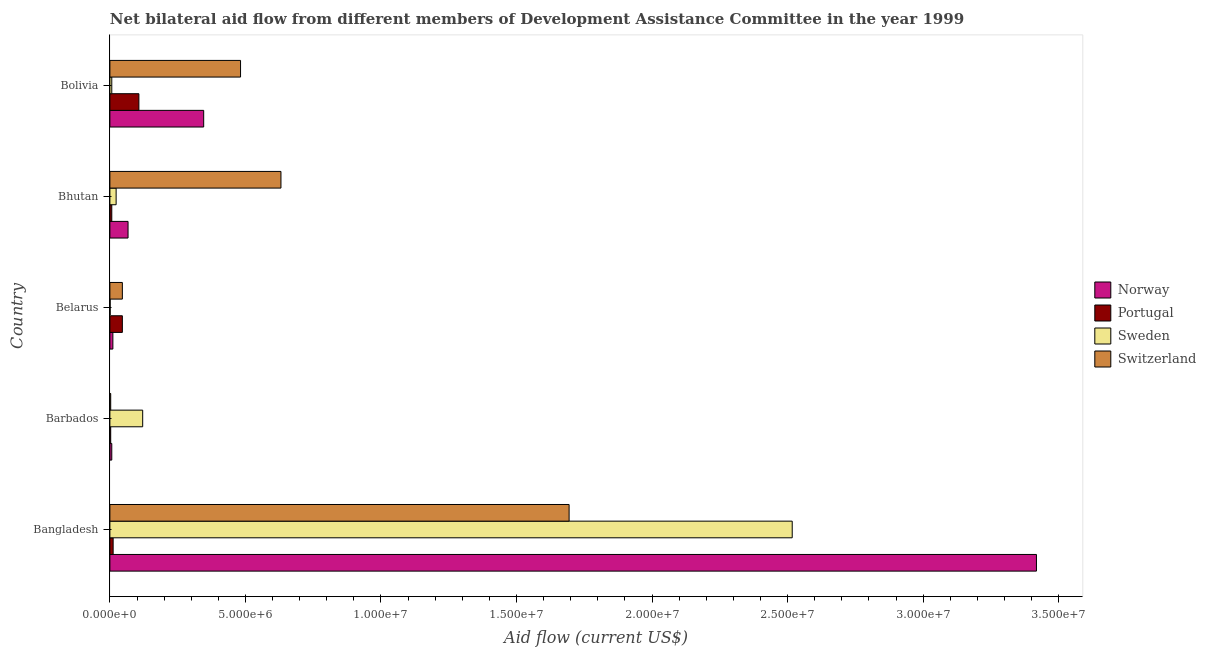How many groups of bars are there?
Your response must be concise. 5. Are the number of bars per tick equal to the number of legend labels?
Give a very brief answer. Yes. What is the label of the 4th group of bars from the top?
Provide a short and direct response. Barbados. In how many cases, is the number of bars for a given country not equal to the number of legend labels?
Your response must be concise. 0. What is the amount of aid given by switzerland in Belarus?
Provide a succinct answer. 4.60e+05. Across all countries, what is the maximum amount of aid given by portugal?
Keep it short and to the point. 1.07e+06. Across all countries, what is the minimum amount of aid given by portugal?
Provide a succinct answer. 3.00e+04. In which country was the amount of aid given by switzerland maximum?
Provide a succinct answer. Bangladesh. In which country was the amount of aid given by switzerland minimum?
Ensure brevity in your answer.  Barbados. What is the total amount of aid given by norway in the graph?
Give a very brief answer. 3.85e+07. What is the difference between the amount of aid given by sweden in Barbados and that in Belarus?
Offer a very short reply. 1.20e+06. What is the difference between the amount of aid given by switzerland in Bangladesh and the amount of aid given by norway in Belarus?
Provide a succinct answer. 1.68e+07. What is the difference between the amount of aid given by portugal and amount of aid given by switzerland in Belarus?
Provide a succinct answer. 0. What is the ratio of the amount of aid given by switzerland in Bangladesh to that in Bhutan?
Offer a terse response. 2.69. What is the difference between the highest and the second highest amount of aid given by portugal?
Offer a very short reply. 6.10e+05. What is the difference between the highest and the lowest amount of aid given by sweden?
Give a very brief answer. 2.52e+07. In how many countries, is the amount of aid given by norway greater than the average amount of aid given by norway taken over all countries?
Offer a terse response. 1. Is it the case that in every country, the sum of the amount of aid given by portugal and amount of aid given by switzerland is greater than the sum of amount of aid given by norway and amount of aid given by sweden?
Keep it short and to the point. No. What does the 3rd bar from the top in Barbados represents?
Give a very brief answer. Portugal. What does the 2nd bar from the bottom in Bolivia represents?
Your response must be concise. Portugal. Is it the case that in every country, the sum of the amount of aid given by norway and amount of aid given by portugal is greater than the amount of aid given by sweden?
Provide a succinct answer. No. What is the difference between two consecutive major ticks on the X-axis?
Keep it short and to the point. 5.00e+06. How many legend labels are there?
Your answer should be very brief. 4. What is the title of the graph?
Offer a terse response. Net bilateral aid flow from different members of Development Assistance Committee in the year 1999. Does "Secondary schools" appear as one of the legend labels in the graph?
Your answer should be very brief. No. What is the Aid flow (current US$) of Norway in Bangladesh?
Your answer should be compact. 3.42e+07. What is the Aid flow (current US$) of Sweden in Bangladesh?
Your response must be concise. 2.52e+07. What is the Aid flow (current US$) in Switzerland in Bangladesh?
Keep it short and to the point. 1.69e+07. What is the Aid flow (current US$) of Norway in Barbados?
Provide a short and direct response. 7.00e+04. What is the Aid flow (current US$) in Sweden in Barbados?
Offer a very short reply. 1.21e+06. What is the Aid flow (current US$) of Switzerland in Barbados?
Provide a succinct answer. 3.00e+04. What is the Aid flow (current US$) in Norway in Bhutan?
Offer a terse response. 6.70e+05. What is the Aid flow (current US$) of Portugal in Bhutan?
Keep it short and to the point. 7.00e+04. What is the Aid flow (current US$) of Sweden in Bhutan?
Your answer should be very brief. 2.30e+05. What is the Aid flow (current US$) of Switzerland in Bhutan?
Offer a very short reply. 6.31e+06. What is the Aid flow (current US$) in Norway in Bolivia?
Offer a very short reply. 3.46e+06. What is the Aid flow (current US$) in Portugal in Bolivia?
Ensure brevity in your answer.  1.07e+06. What is the Aid flow (current US$) of Switzerland in Bolivia?
Offer a terse response. 4.82e+06. Across all countries, what is the maximum Aid flow (current US$) in Norway?
Make the answer very short. 3.42e+07. Across all countries, what is the maximum Aid flow (current US$) of Portugal?
Offer a terse response. 1.07e+06. Across all countries, what is the maximum Aid flow (current US$) of Sweden?
Provide a succinct answer. 2.52e+07. Across all countries, what is the maximum Aid flow (current US$) in Switzerland?
Offer a very short reply. 1.69e+07. Across all countries, what is the minimum Aid flow (current US$) in Norway?
Provide a short and direct response. 7.00e+04. Across all countries, what is the minimum Aid flow (current US$) in Portugal?
Offer a very short reply. 3.00e+04. Across all countries, what is the minimum Aid flow (current US$) in Sweden?
Offer a terse response. 10000. What is the total Aid flow (current US$) in Norway in the graph?
Your answer should be very brief. 3.85e+07. What is the total Aid flow (current US$) of Portugal in the graph?
Your answer should be very brief. 1.75e+06. What is the total Aid flow (current US$) in Sweden in the graph?
Your answer should be very brief. 2.67e+07. What is the total Aid flow (current US$) of Switzerland in the graph?
Your answer should be very brief. 2.86e+07. What is the difference between the Aid flow (current US$) in Norway in Bangladesh and that in Barbados?
Give a very brief answer. 3.41e+07. What is the difference between the Aid flow (current US$) of Portugal in Bangladesh and that in Barbados?
Provide a succinct answer. 9.00e+04. What is the difference between the Aid flow (current US$) in Sweden in Bangladesh and that in Barbados?
Provide a short and direct response. 2.40e+07. What is the difference between the Aid flow (current US$) of Switzerland in Bangladesh and that in Barbados?
Give a very brief answer. 1.69e+07. What is the difference between the Aid flow (current US$) in Norway in Bangladesh and that in Belarus?
Offer a very short reply. 3.41e+07. What is the difference between the Aid flow (current US$) in Portugal in Bangladesh and that in Belarus?
Your response must be concise. -3.40e+05. What is the difference between the Aid flow (current US$) of Sweden in Bangladesh and that in Belarus?
Give a very brief answer. 2.52e+07. What is the difference between the Aid flow (current US$) in Switzerland in Bangladesh and that in Belarus?
Give a very brief answer. 1.65e+07. What is the difference between the Aid flow (current US$) in Norway in Bangladesh and that in Bhutan?
Provide a succinct answer. 3.35e+07. What is the difference between the Aid flow (current US$) in Portugal in Bangladesh and that in Bhutan?
Give a very brief answer. 5.00e+04. What is the difference between the Aid flow (current US$) of Sweden in Bangladesh and that in Bhutan?
Ensure brevity in your answer.  2.49e+07. What is the difference between the Aid flow (current US$) in Switzerland in Bangladesh and that in Bhutan?
Give a very brief answer. 1.06e+07. What is the difference between the Aid flow (current US$) in Norway in Bangladesh and that in Bolivia?
Make the answer very short. 3.07e+07. What is the difference between the Aid flow (current US$) of Portugal in Bangladesh and that in Bolivia?
Your answer should be compact. -9.50e+05. What is the difference between the Aid flow (current US$) in Sweden in Bangladesh and that in Bolivia?
Your answer should be very brief. 2.51e+07. What is the difference between the Aid flow (current US$) of Switzerland in Bangladesh and that in Bolivia?
Offer a very short reply. 1.21e+07. What is the difference between the Aid flow (current US$) in Portugal in Barbados and that in Belarus?
Provide a succinct answer. -4.30e+05. What is the difference between the Aid flow (current US$) in Sweden in Barbados and that in Belarus?
Offer a very short reply. 1.20e+06. What is the difference between the Aid flow (current US$) of Switzerland in Barbados and that in Belarus?
Keep it short and to the point. -4.30e+05. What is the difference between the Aid flow (current US$) of Norway in Barbados and that in Bhutan?
Give a very brief answer. -6.00e+05. What is the difference between the Aid flow (current US$) in Portugal in Barbados and that in Bhutan?
Your answer should be very brief. -4.00e+04. What is the difference between the Aid flow (current US$) in Sweden in Barbados and that in Bhutan?
Make the answer very short. 9.80e+05. What is the difference between the Aid flow (current US$) in Switzerland in Barbados and that in Bhutan?
Your answer should be compact. -6.28e+06. What is the difference between the Aid flow (current US$) in Norway in Barbados and that in Bolivia?
Ensure brevity in your answer.  -3.39e+06. What is the difference between the Aid flow (current US$) in Portugal in Barbados and that in Bolivia?
Offer a very short reply. -1.04e+06. What is the difference between the Aid flow (current US$) of Sweden in Barbados and that in Bolivia?
Offer a terse response. 1.14e+06. What is the difference between the Aid flow (current US$) in Switzerland in Barbados and that in Bolivia?
Offer a very short reply. -4.79e+06. What is the difference between the Aid flow (current US$) in Norway in Belarus and that in Bhutan?
Give a very brief answer. -5.60e+05. What is the difference between the Aid flow (current US$) in Portugal in Belarus and that in Bhutan?
Provide a short and direct response. 3.90e+05. What is the difference between the Aid flow (current US$) of Sweden in Belarus and that in Bhutan?
Provide a short and direct response. -2.20e+05. What is the difference between the Aid flow (current US$) in Switzerland in Belarus and that in Bhutan?
Provide a succinct answer. -5.85e+06. What is the difference between the Aid flow (current US$) of Norway in Belarus and that in Bolivia?
Your answer should be compact. -3.35e+06. What is the difference between the Aid flow (current US$) in Portugal in Belarus and that in Bolivia?
Offer a terse response. -6.10e+05. What is the difference between the Aid flow (current US$) of Sweden in Belarus and that in Bolivia?
Provide a short and direct response. -6.00e+04. What is the difference between the Aid flow (current US$) in Switzerland in Belarus and that in Bolivia?
Provide a succinct answer. -4.36e+06. What is the difference between the Aid flow (current US$) in Norway in Bhutan and that in Bolivia?
Provide a succinct answer. -2.79e+06. What is the difference between the Aid flow (current US$) of Portugal in Bhutan and that in Bolivia?
Ensure brevity in your answer.  -1.00e+06. What is the difference between the Aid flow (current US$) of Sweden in Bhutan and that in Bolivia?
Keep it short and to the point. 1.60e+05. What is the difference between the Aid flow (current US$) in Switzerland in Bhutan and that in Bolivia?
Offer a very short reply. 1.49e+06. What is the difference between the Aid flow (current US$) of Norway in Bangladesh and the Aid flow (current US$) of Portugal in Barbados?
Provide a short and direct response. 3.42e+07. What is the difference between the Aid flow (current US$) in Norway in Bangladesh and the Aid flow (current US$) in Sweden in Barbados?
Offer a terse response. 3.30e+07. What is the difference between the Aid flow (current US$) in Norway in Bangladesh and the Aid flow (current US$) in Switzerland in Barbados?
Offer a terse response. 3.42e+07. What is the difference between the Aid flow (current US$) of Portugal in Bangladesh and the Aid flow (current US$) of Sweden in Barbados?
Give a very brief answer. -1.09e+06. What is the difference between the Aid flow (current US$) in Sweden in Bangladesh and the Aid flow (current US$) in Switzerland in Barbados?
Make the answer very short. 2.51e+07. What is the difference between the Aid flow (current US$) in Norway in Bangladesh and the Aid flow (current US$) in Portugal in Belarus?
Your answer should be compact. 3.37e+07. What is the difference between the Aid flow (current US$) of Norway in Bangladesh and the Aid flow (current US$) of Sweden in Belarus?
Provide a succinct answer. 3.42e+07. What is the difference between the Aid flow (current US$) of Norway in Bangladesh and the Aid flow (current US$) of Switzerland in Belarus?
Your response must be concise. 3.37e+07. What is the difference between the Aid flow (current US$) in Sweden in Bangladesh and the Aid flow (current US$) in Switzerland in Belarus?
Your answer should be compact. 2.47e+07. What is the difference between the Aid flow (current US$) of Norway in Bangladesh and the Aid flow (current US$) of Portugal in Bhutan?
Provide a succinct answer. 3.41e+07. What is the difference between the Aid flow (current US$) in Norway in Bangladesh and the Aid flow (current US$) in Sweden in Bhutan?
Offer a terse response. 3.40e+07. What is the difference between the Aid flow (current US$) of Norway in Bangladesh and the Aid flow (current US$) of Switzerland in Bhutan?
Your answer should be very brief. 2.79e+07. What is the difference between the Aid flow (current US$) in Portugal in Bangladesh and the Aid flow (current US$) in Sweden in Bhutan?
Your response must be concise. -1.10e+05. What is the difference between the Aid flow (current US$) in Portugal in Bangladesh and the Aid flow (current US$) in Switzerland in Bhutan?
Provide a succinct answer. -6.19e+06. What is the difference between the Aid flow (current US$) in Sweden in Bangladesh and the Aid flow (current US$) in Switzerland in Bhutan?
Offer a terse response. 1.89e+07. What is the difference between the Aid flow (current US$) in Norway in Bangladesh and the Aid flow (current US$) in Portugal in Bolivia?
Your response must be concise. 3.31e+07. What is the difference between the Aid flow (current US$) of Norway in Bangladesh and the Aid flow (current US$) of Sweden in Bolivia?
Provide a succinct answer. 3.41e+07. What is the difference between the Aid flow (current US$) in Norway in Bangladesh and the Aid flow (current US$) in Switzerland in Bolivia?
Provide a short and direct response. 2.94e+07. What is the difference between the Aid flow (current US$) of Portugal in Bangladesh and the Aid flow (current US$) of Switzerland in Bolivia?
Offer a terse response. -4.70e+06. What is the difference between the Aid flow (current US$) of Sweden in Bangladesh and the Aid flow (current US$) of Switzerland in Bolivia?
Make the answer very short. 2.04e+07. What is the difference between the Aid flow (current US$) of Norway in Barbados and the Aid flow (current US$) of Portugal in Belarus?
Provide a succinct answer. -3.90e+05. What is the difference between the Aid flow (current US$) of Norway in Barbados and the Aid flow (current US$) of Switzerland in Belarus?
Ensure brevity in your answer.  -3.90e+05. What is the difference between the Aid flow (current US$) of Portugal in Barbados and the Aid flow (current US$) of Switzerland in Belarus?
Give a very brief answer. -4.30e+05. What is the difference between the Aid flow (current US$) of Sweden in Barbados and the Aid flow (current US$) of Switzerland in Belarus?
Give a very brief answer. 7.50e+05. What is the difference between the Aid flow (current US$) of Norway in Barbados and the Aid flow (current US$) of Sweden in Bhutan?
Give a very brief answer. -1.60e+05. What is the difference between the Aid flow (current US$) in Norway in Barbados and the Aid flow (current US$) in Switzerland in Bhutan?
Ensure brevity in your answer.  -6.24e+06. What is the difference between the Aid flow (current US$) of Portugal in Barbados and the Aid flow (current US$) of Sweden in Bhutan?
Provide a short and direct response. -2.00e+05. What is the difference between the Aid flow (current US$) in Portugal in Barbados and the Aid flow (current US$) in Switzerland in Bhutan?
Provide a succinct answer. -6.28e+06. What is the difference between the Aid flow (current US$) of Sweden in Barbados and the Aid flow (current US$) of Switzerland in Bhutan?
Make the answer very short. -5.10e+06. What is the difference between the Aid flow (current US$) of Norway in Barbados and the Aid flow (current US$) of Sweden in Bolivia?
Keep it short and to the point. 0. What is the difference between the Aid flow (current US$) in Norway in Barbados and the Aid flow (current US$) in Switzerland in Bolivia?
Ensure brevity in your answer.  -4.75e+06. What is the difference between the Aid flow (current US$) in Portugal in Barbados and the Aid flow (current US$) in Switzerland in Bolivia?
Keep it short and to the point. -4.79e+06. What is the difference between the Aid flow (current US$) of Sweden in Barbados and the Aid flow (current US$) of Switzerland in Bolivia?
Your answer should be compact. -3.61e+06. What is the difference between the Aid flow (current US$) in Norway in Belarus and the Aid flow (current US$) in Portugal in Bhutan?
Your answer should be compact. 4.00e+04. What is the difference between the Aid flow (current US$) in Norway in Belarus and the Aid flow (current US$) in Switzerland in Bhutan?
Make the answer very short. -6.20e+06. What is the difference between the Aid flow (current US$) in Portugal in Belarus and the Aid flow (current US$) in Switzerland in Bhutan?
Ensure brevity in your answer.  -5.85e+06. What is the difference between the Aid flow (current US$) in Sweden in Belarus and the Aid flow (current US$) in Switzerland in Bhutan?
Your answer should be very brief. -6.30e+06. What is the difference between the Aid flow (current US$) in Norway in Belarus and the Aid flow (current US$) in Portugal in Bolivia?
Make the answer very short. -9.60e+05. What is the difference between the Aid flow (current US$) in Norway in Belarus and the Aid flow (current US$) in Switzerland in Bolivia?
Offer a very short reply. -4.71e+06. What is the difference between the Aid flow (current US$) of Portugal in Belarus and the Aid flow (current US$) of Sweden in Bolivia?
Your answer should be very brief. 3.90e+05. What is the difference between the Aid flow (current US$) in Portugal in Belarus and the Aid flow (current US$) in Switzerland in Bolivia?
Offer a very short reply. -4.36e+06. What is the difference between the Aid flow (current US$) in Sweden in Belarus and the Aid flow (current US$) in Switzerland in Bolivia?
Provide a succinct answer. -4.81e+06. What is the difference between the Aid flow (current US$) in Norway in Bhutan and the Aid flow (current US$) in Portugal in Bolivia?
Keep it short and to the point. -4.00e+05. What is the difference between the Aid flow (current US$) of Norway in Bhutan and the Aid flow (current US$) of Switzerland in Bolivia?
Make the answer very short. -4.15e+06. What is the difference between the Aid flow (current US$) in Portugal in Bhutan and the Aid flow (current US$) in Sweden in Bolivia?
Offer a very short reply. 0. What is the difference between the Aid flow (current US$) of Portugal in Bhutan and the Aid flow (current US$) of Switzerland in Bolivia?
Your response must be concise. -4.75e+06. What is the difference between the Aid flow (current US$) of Sweden in Bhutan and the Aid flow (current US$) of Switzerland in Bolivia?
Give a very brief answer. -4.59e+06. What is the average Aid flow (current US$) in Norway per country?
Provide a short and direct response. 7.70e+06. What is the average Aid flow (current US$) in Portugal per country?
Give a very brief answer. 3.50e+05. What is the average Aid flow (current US$) of Sweden per country?
Your answer should be compact. 5.34e+06. What is the average Aid flow (current US$) in Switzerland per country?
Provide a succinct answer. 5.71e+06. What is the difference between the Aid flow (current US$) in Norway and Aid flow (current US$) in Portugal in Bangladesh?
Offer a very short reply. 3.41e+07. What is the difference between the Aid flow (current US$) of Norway and Aid flow (current US$) of Sweden in Bangladesh?
Provide a short and direct response. 9.01e+06. What is the difference between the Aid flow (current US$) in Norway and Aid flow (current US$) in Switzerland in Bangladesh?
Offer a terse response. 1.72e+07. What is the difference between the Aid flow (current US$) of Portugal and Aid flow (current US$) of Sweden in Bangladesh?
Keep it short and to the point. -2.50e+07. What is the difference between the Aid flow (current US$) of Portugal and Aid flow (current US$) of Switzerland in Bangladesh?
Provide a succinct answer. -1.68e+07. What is the difference between the Aid flow (current US$) in Sweden and Aid flow (current US$) in Switzerland in Bangladesh?
Your answer should be very brief. 8.23e+06. What is the difference between the Aid flow (current US$) of Norway and Aid flow (current US$) of Portugal in Barbados?
Offer a very short reply. 4.00e+04. What is the difference between the Aid flow (current US$) of Norway and Aid flow (current US$) of Sweden in Barbados?
Your response must be concise. -1.14e+06. What is the difference between the Aid flow (current US$) of Norway and Aid flow (current US$) of Switzerland in Barbados?
Give a very brief answer. 4.00e+04. What is the difference between the Aid flow (current US$) of Portugal and Aid flow (current US$) of Sweden in Barbados?
Your answer should be very brief. -1.18e+06. What is the difference between the Aid flow (current US$) of Portugal and Aid flow (current US$) of Switzerland in Barbados?
Offer a very short reply. 0. What is the difference between the Aid flow (current US$) of Sweden and Aid flow (current US$) of Switzerland in Barbados?
Make the answer very short. 1.18e+06. What is the difference between the Aid flow (current US$) of Norway and Aid flow (current US$) of Portugal in Belarus?
Give a very brief answer. -3.50e+05. What is the difference between the Aid flow (current US$) of Norway and Aid flow (current US$) of Sweden in Belarus?
Provide a short and direct response. 1.00e+05. What is the difference between the Aid flow (current US$) in Norway and Aid flow (current US$) in Switzerland in Belarus?
Provide a succinct answer. -3.50e+05. What is the difference between the Aid flow (current US$) in Portugal and Aid flow (current US$) in Switzerland in Belarus?
Make the answer very short. 0. What is the difference between the Aid flow (current US$) in Sweden and Aid flow (current US$) in Switzerland in Belarus?
Offer a very short reply. -4.50e+05. What is the difference between the Aid flow (current US$) of Norway and Aid flow (current US$) of Sweden in Bhutan?
Make the answer very short. 4.40e+05. What is the difference between the Aid flow (current US$) in Norway and Aid flow (current US$) in Switzerland in Bhutan?
Offer a very short reply. -5.64e+06. What is the difference between the Aid flow (current US$) of Portugal and Aid flow (current US$) of Switzerland in Bhutan?
Provide a short and direct response. -6.24e+06. What is the difference between the Aid flow (current US$) of Sweden and Aid flow (current US$) of Switzerland in Bhutan?
Your answer should be very brief. -6.08e+06. What is the difference between the Aid flow (current US$) of Norway and Aid flow (current US$) of Portugal in Bolivia?
Your answer should be very brief. 2.39e+06. What is the difference between the Aid flow (current US$) of Norway and Aid flow (current US$) of Sweden in Bolivia?
Provide a succinct answer. 3.39e+06. What is the difference between the Aid flow (current US$) of Norway and Aid flow (current US$) of Switzerland in Bolivia?
Ensure brevity in your answer.  -1.36e+06. What is the difference between the Aid flow (current US$) of Portugal and Aid flow (current US$) of Switzerland in Bolivia?
Your response must be concise. -3.75e+06. What is the difference between the Aid flow (current US$) of Sweden and Aid flow (current US$) of Switzerland in Bolivia?
Offer a terse response. -4.75e+06. What is the ratio of the Aid flow (current US$) of Norway in Bangladesh to that in Barbados?
Give a very brief answer. 488.29. What is the ratio of the Aid flow (current US$) in Portugal in Bangladesh to that in Barbados?
Your response must be concise. 4. What is the ratio of the Aid flow (current US$) in Sweden in Bangladesh to that in Barbados?
Ensure brevity in your answer.  20.8. What is the ratio of the Aid flow (current US$) in Switzerland in Bangladesh to that in Barbados?
Your response must be concise. 564.67. What is the ratio of the Aid flow (current US$) in Norway in Bangladesh to that in Belarus?
Provide a succinct answer. 310.73. What is the ratio of the Aid flow (current US$) in Portugal in Bangladesh to that in Belarus?
Your response must be concise. 0.26. What is the ratio of the Aid flow (current US$) of Sweden in Bangladesh to that in Belarus?
Give a very brief answer. 2517. What is the ratio of the Aid flow (current US$) in Switzerland in Bangladesh to that in Belarus?
Offer a terse response. 36.83. What is the ratio of the Aid flow (current US$) of Norway in Bangladesh to that in Bhutan?
Give a very brief answer. 51.01. What is the ratio of the Aid flow (current US$) in Portugal in Bangladesh to that in Bhutan?
Ensure brevity in your answer.  1.71. What is the ratio of the Aid flow (current US$) of Sweden in Bangladesh to that in Bhutan?
Your answer should be very brief. 109.43. What is the ratio of the Aid flow (current US$) in Switzerland in Bangladesh to that in Bhutan?
Keep it short and to the point. 2.68. What is the ratio of the Aid flow (current US$) in Norway in Bangladesh to that in Bolivia?
Give a very brief answer. 9.88. What is the ratio of the Aid flow (current US$) in Portugal in Bangladesh to that in Bolivia?
Give a very brief answer. 0.11. What is the ratio of the Aid flow (current US$) in Sweden in Bangladesh to that in Bolivia?
Offer a very short reply. 359.57. What is the ratio of the Aid flow (current US$) in Switzerland in Bangladesh to that in Bolivia?
Offer a terse response. 3.51. What is the ratio of the Aid flow (current US$) of Norway in Barbados to that in Belarus?
Provide a succinct answer. 0.64. What is the ratio of the Aid flow (current US$) in Portugal in Barbados to that in Belarus?
Offer a very short reply. 0.07. What is the ratio of the Aid flow (current US$) of Sweden in Barbados to that in Belarus?
Offer a very short reply. 121. What is the ratio of the Aid flow (current US$) in Switzerland in Barbados to that in Belarus?
Provide a short and direct response. 0.07. What is the ratio of the Aid flow (current US$) in Norway in Barbados to that in Bhutan?
Give a very brief answer. 0.1. What is the ratio of the Aid flow (current US$) of Portugal in Barbados to that in Bhutan?
Your response must be concise. 0.43. What is the ratio of the Aid flow (current US$) in Sweden in Barbados to that in Bhutan?
Keep it short and to the point. 5.26. What is the ratio of the Aid flow (current US$) in Switzerland in Barbados to that in Bhutan?
Your answer should be very brief. 0. What is the ratio of the Aid flow (current US$) in Norway in Barbados to that in Bolivia?
Offer a terse response. 0.02. What is the ratio of the Aid flow (current US$) in Portugal in Barbados to that in Bolivia?
Your answer should be compact. 0.03. What is the ratio of the Aid flow (current US$) of Sweden in Barbados to that in Bolivia?
Make the answer very short. 17.29. What is the ratio of the Aid flow (current US$) in Switzerland in Barbados to that in Bolivia?
Your answer should be very brief. 0.01. What is the ratio of the Aid flow (current US$) in Norway in Belarus to that in Bhutan?
Provide a succinct answer. 0.16. What is the ratio of the Aid flow (current US$) of Portugal in Belarus to that in Bhutan?
Offer a terse response. 6.57. What is the ratio of the Aid flow (current US$) in Sweden in Belarus to that in Bhutan?
Your response must be concise. 0.04. What is the ratio of the Aid flow (current US$) in Switzerland in Belarus to that in Bhutan?
Provide a succinct answer. 0.07. What is the ratio of the Aid flow (current US$) in Norway in Belarus to that in Bolivia?
Your response must be concise. 0.03. What is the ratio of the Aid flow (current US$) of Portugal in Belarus to that in Bolivia?
Provide a short and direct response. 0.43. What is the ratio of the Aid flow (current US$) of Sweden in Belarus to that in Bolivia?
Offer a terse response. 0.14. What is the ratio of the Aid flow (current US$) in Switzerland in Belarus to that in Bolivia?
Your response must be concise. 0.1. What is the ratio of the Aid flow (current US$) in Norway in Bhutan to that in Bolivia?
Make the answer very short. 0.19. What is the ratio of the Aid flow (current US$) of Portugal in Bhutan to that in Bolivia?
Offer a very short reply. 0.07. What is the ratio of the Aid flow (current US$) of Sweden in Bhutan to that in Bolivia?
Offer a terse response. 3.29. What is the ratio of the Aid flow (current US$) of Switzerland in Bhutan to that in Bolivia?
Keep it short and to the point. 1.31. What is the difference between the highest and the second highest Aid flow (current US$) in Norway?
Your answer should be very brief. 3.07e+07. What is the difference between the highest and the second highest Aid flow (current US$) of Portugal?
Provide a short and direct response. 6.10e+05. What is the difference between the highest and the second highest Aid flow (current US$) of Sweden?
Keep it short and to the point. 2.40e+07. What is the difference between the highest and the second highest Aid flow (current US$) of Switzerland?
Make the answer very short. 1.06e+07. What is the difference between the highest and the lowest Aid flow (current US$) of Norway?
Your response must be concise. 3.41e+07. What is the difference between the highest and the lowest Aid flow (current US$) in Portugal?
Keep it short and to the point. 1.04e+06. What is the difference between the highest and the lowest Aid flow (current US$) of Sweden?
Make the answer very short. 2.52e+07. What is the difference between the highest and the lowest Aid flow (current US$) of Switzerland?
Keep it short and to the point. 1.69e+07. 